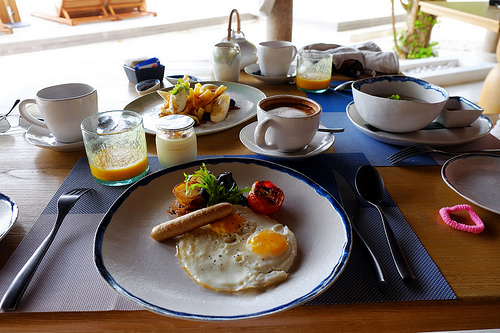<image>
Is the bacon next to the grits? No. The bacon is not positioned next to the grits. They are located in different areas of the scene. 